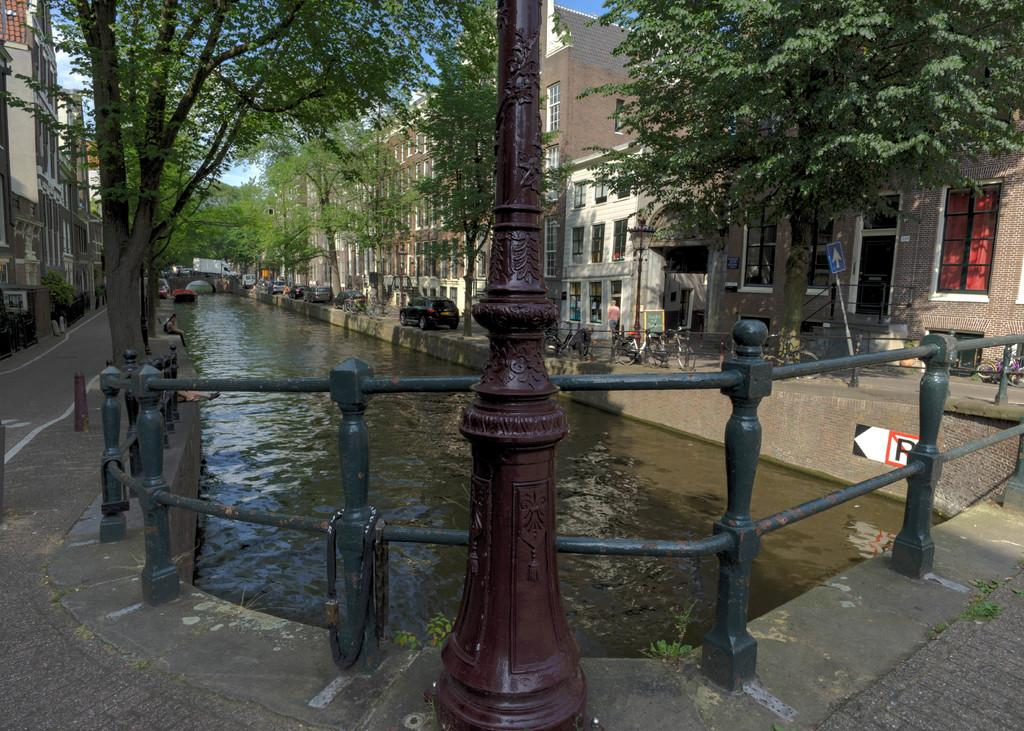What type of barrier can be seen in the image? There is a fence in the image. What vertical structure is present in the image? There is a pole in the image. What natural element is visible in the image? There is water visible in the image. What type of man-made structure is present in the image? There is a wall in the image. What can be seen in the distance in the image? There are buildings, trees, and vehicles in the background of the image. What type of vegetation is present in the image? There are plants in the background of the image. What is the person in the image doing? There is a person walking in the image. What part of the natural environment is visible in the image? The sky is visible in the image. Where is the drawer located in the image? There is no drawer present in the image. What type of stick is being used by the person walking in the image? There is no stick visible in the image; the person is simply walking. 